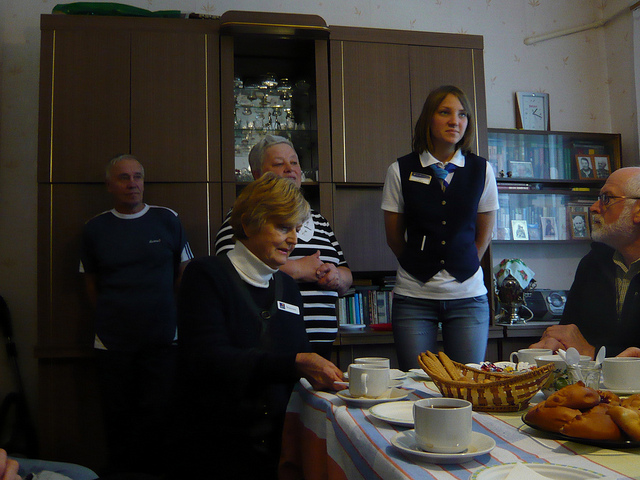<image>Are the people enjoying themselves? I am not sure if the people are enjoying themselves. It could be both yes or no. What does the woman have around her waist? I am not sure what the woman has around her waist. It could be clothing, a belt, or nothing. Is the man in the background on the left wearing a watch? I don't know if the man in the background on the left is wearing a watch. The answer can be both yes and no. Are the people enjoying themselves? I don't know if the people are enjoying themselves. It can be both yes and no. What does the woman have around her waist? I don't know what the woman has around her waist. It can be seen as vest, clothing, pants, or belt. Is the man in the background on the left wearing a watch? I am not sure if the man in the background on the left is wearing a watch. It can be both yes or no. 